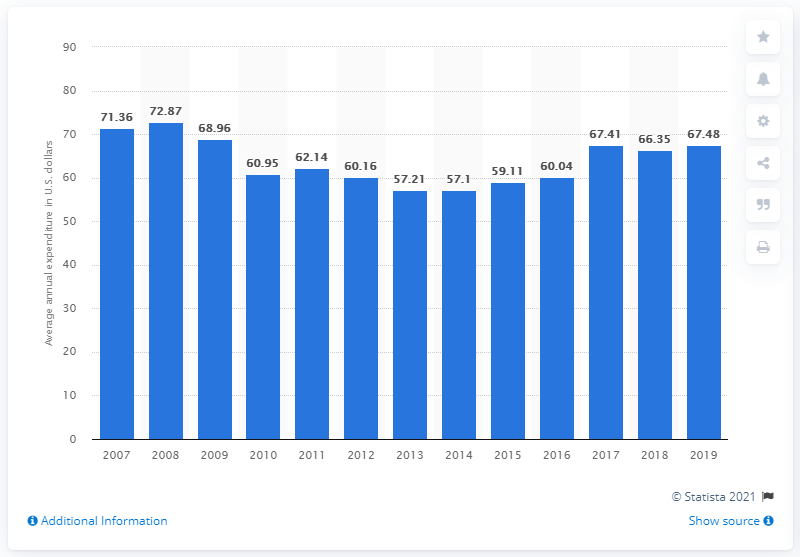Highlight a few significant elements in this photo. In the United States in 2019, the average annual expenditure on frozen meals per consumer unit was $67.48. 